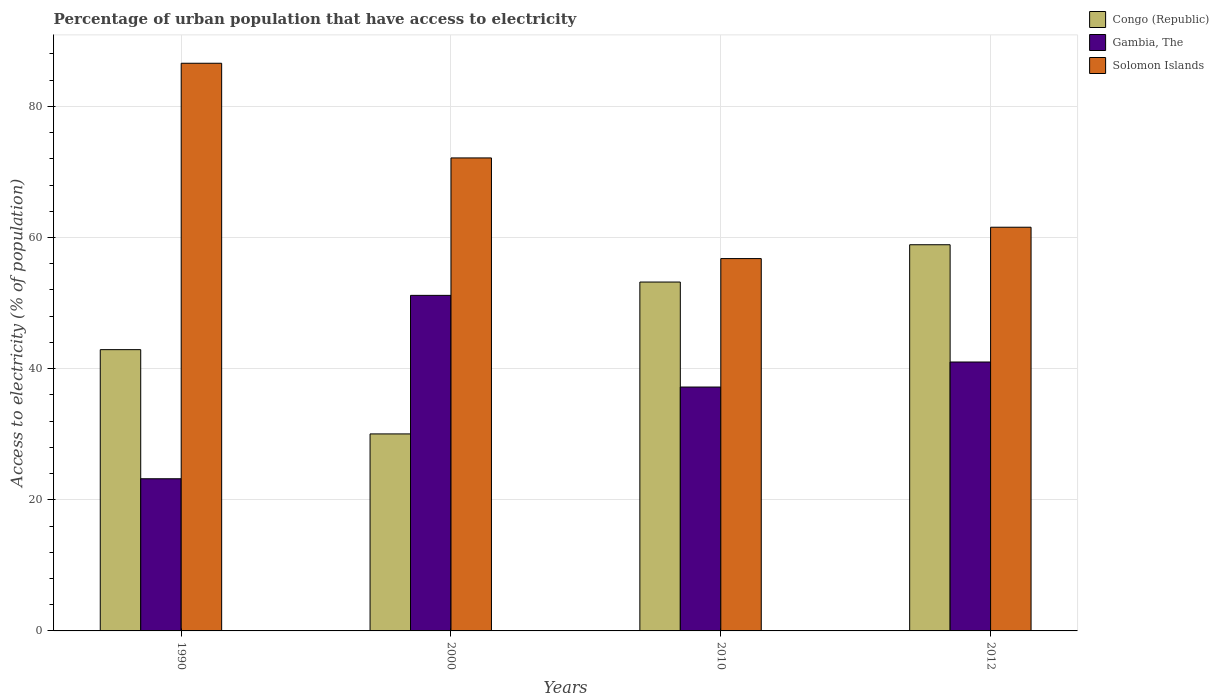How many different coloured bars are there?
Ensure brevity in your answer.  3. How many groups of bars are there?
Give a very brief answer. 4. Are the number of bars per tick equal to the number of legend labels?
Your response must be concise. Yes. How many bars are there on the 2nd tick from the left?
Make the answer very short. 3. What is the label of the 1st group of bars from the left?
Your answer should be compact. 1990. In how many cases, is the number of bars for a given year not equal to the number of legend labels?
Your answer should be very brief. 0. What is the percentage of urban population that have access to electricity in Solomon Islands in 2000?
Your answer should be compact. 72.14. Across all years, what is the maximum percentage of urban population that have access to electricity in Solomon Islands?
Ensure brevity in your answer.  86.58. Across all years, what is the minimum percentage of urban population that have access to electricity in Solomon Islands?
Your answer should be compact. 56.79. In which year was the percentage of urban population that have access to electricity in Congo (Republic) minimum?
Your answer should be compact. 2000. What is the total percentage of urban population that have access to electricity in Gambia, The in the graph?
Your answer should be compact. 152.6. What is the difference between the percentage of urban population that have access to electricity in Gambia, The in 1990 and that in 2010?
Offer a very short reply. -13.99. What is the difference between the percentage of urban population that have access to electricity in Congo (Republic) in 2000 and the percentage of urban population that have access to electricity in Gambia, The in 1990?
Your answer should be compact. 6.84. What is the average percentage of urban population that have access to electricity in Congo (Republic) per year?
Keep it short and to the point. 46.27. In the year 1990, what is the difference between the percentage of urban population that have access to electricity in Gambia, The and percentage of urban population that have access to electricity in Solomon Islands?
Ensure brevity in your answer.  -63.37. What is the ratio of the percentage of urban population that have access to electricity in Solomon Islands in 1990 to that in 2012?
Offer a terse response. 1.41. Is the difference between the percentage of urban population that have access to electricity in Gambia, The in 1990 and 2010 greater than the difference between the percentage of urban population that have access to electricity in Solomon Islands in 1990 and 2010?
Offer a very short reply. No. What is the difference between the highest and the second highest percentage of urban population that have access to electricity in Solomon Islands?
Make the answer very short. 14.44. What is the difference between the highest and the lowest percentage of urban population that have access to electricity in Solomon Islands?
Your answer should be compact. 29.79. Is the sum of the percentage of urban population that have access to electricity in Congo (Republic) in 1990 and 2010 greater than the maximum percentage of urban population that have access to electricity in Solomon Islands across all years?
Offer a terse response. Yes. What does the 3rd bar from the left in 2012 represents?
Your response must be concise. Solomon Islands. What does the 1st bar from the right in 2010 represents?
Offer a terse response. Solomon Islands. How many bars are there?
Offer a terse response. 12. Are all the bars in the graph horizontal?
Keep it short and to the point. No. How many years are there in the graph?
Your answer should be very brief. 4. Does the graph contain any zero values?
Offer a very short reply. No. Does the graph contain grids?
Provide a short and direct response. Yes. What is the title of the graph?
Ensure brevity in your answer.  Percentage of urban population that have access to electricity. Does "North America" appear as one of the legend labels in the graph?
Make the answer very short. No. What is the label or title of the Y-axis?
Offer a very short reply. Access to electricity (% of population). What is the Access to electricity (% of population) of Congo (Republic) in 1990?
Your answer should be compact. 42.9. What is the Access to electricity (% of population) of Gambia, The in 1990?
Provide a succinct answer. 23.21. What is the Access to electricity (% of population) of Solomon Islands in 1990?
Provide a succinct answer. 86.58. What is the Access to electricity (% of population) of Congo (Republic) in 2000?
Offer a very short reply. 30.05. What is the Access to electricity (% of population) of Gambia, The in 2000?
Offer a terse response. 51.18. What is the Access to electricity (% of population) of Solomon Islands in 2000?
Offer a very short reply. 72.14. What is the Access to electricity (% of population) in Congo (Republic) in 2010?
Make the answer very short. 53.21. What is the Access to electricity (% of population) of Gambia, The in 2010?
Offer a terse response. 37.2. What is the Access to electricity (% of population) in Solomon Islands in 2010?
Keep it short and to the point. 56.79. What is the Access to electricity (% of population) in Congo (Republic) in 2012?
Keep it short and to the point. 58.9. What is the Access to electricity (% of population) in Gambia, The in 2012?
Make the answer very short. 41.01. What is the Access to electricity (% of population) in Solomon Islands in 2012?
Your response must be concise. 61.57. Across all years, what is the maximum Access to electricity (% of population) in Congo (Republic)?
Offer a terse response. 58.9. Across all years, what is the maximum Access to electricity (% of population) of Gambia, The?
Provide a succinct answer. 51.18. Across all years, what is the maximum Access to electricity (% of population) in Solomon Islands?
Your answer should be very brief. 86.58. Across all years, what is the minimum Access to electricity (% of population) in Congo (Republic)?
Your answer should be very brief. 30.05. Across all years, what is the minimum Access to electricity (% of population) of Gambia, The?
Offer a very short reply. 23.21. Across all years, what is the minimum Access to electricity (% of population) in Solomon Islands?
Your answer should be compact. 56.79. What is the total Access to electricity (% of population) of Congo (Republic) in the graph?
Your answer should be very brief. 185.06. What is the total Access to electricity (% of population) in Gambia, The in the graph?
Your answer should be very brief. 152.6. What is the total Access to electricity (% of population) in Solomon Islands in the graph?
Ensure brevity in your answer.  277.08. What is the difference between the Access to electricity (% of population) in Congo (Republic) in 1990 and that in 2000?
Your answer should be very brief. 12.85. What is the difference between the Access to electricity (% of population) of Gambia, The in 1990 and that in 2000?
Make the answer very short. -27.97. What is the difference between the Access to electricity (% of population) in Solomon Islands in 1990 and that in 2000?
Give a very brief answer. 14.44. What is the difference between the Access to electricity (% of population) of Congo (Republic) in 1990 and that in 2010?
Provide a succinct answer. -10.31. What is the difference between the Access to electricity (% of population) of Gambia, The in 1990 and that in 2010?
Keep it short and to the point. -13.99. What is the difference between the Access to electricity (% of population) in Solomon Islands in 1990 and that in 2010?
Keep it short and to the point. 29.79. What is the difference between the Access to electricity (% of population) of Congo (Republic) in 1990 and that in 2012?
Provide a succinct answer. -16. What is the difference between the Access to electricity (% of population) in Gambia, The in 1990 and that in 2012?
Provide a succinct answer. -17.81. What is the difference between the Access to electricity (% of population) of Solomon Islands in 1990 and that in 2012?
Your answer should be compact. 25.01. What is the difference between the Access to electricity (% of population) of Congo (Republic) in 2000 and that in 2010?
Provide a succinct answer. -23.16. What is the difference between the Access to electricity (% of population) in Gambia, The in 2000 and that in 2010?
Your answer should be compact. 13.98. What is the difference between the Access to electricity (% of population) of Solomon Islands in 2000 and that in 2010?
Give a very brief answer. 15.35. What is the difference between the Access to electricity (% of population) of Congo (Republic) in 2000 and that in 2012?
Provide a short and direct response. -28.85. What is the difference between the Access to electricity (% of population) of Gambia, The in 2000 and that in 2012?
Your answer should be very brief. 10.16. What is the difference between the Access to electricity (% of population) in Solomon Islands in 2000 and that in 2012?
Provide a short and direct response. 10.57. What is the difference between the Access to electricity (% of population) of Congo (Republic) in 2010 and that in 2012?
Your response must be concise. -5.69. What is the difference between the Access to electricity (% of population) in Gambia, The in 2010 and that in 2012?
Ensure brevity in your answer.  -3.82. What is the difference between the Access to electricity (% of population) of Solomon Islands in 2010 and that in 2012?
Provide a succinct answer. -4.78. What is the difference between the Access to electricity (% of population) in Congo (Republic) in 1990 and the Access to electricity (% of population) in Gambia, The in 2000?
Offer a very short reply. -8.28. What is the difference between the Access to electricity (% of population) in Congo (Republic) in 1990 and the Access to electricity (% of population) in Solomon Islands in 2000?
Provide a short and direct response. -29.24. What is the difference between the Access to electricity (% of population) in Gambia, The in 1990 and the Access to electricity (% of population) in Solomon Islands in 2000?
Your answer should be very brief. -48.93. What is the difference between the Access to electricity (% of population) in Congo (Republic) in 1990 and the Access to electricity (% of population) in Gambia, The in 2010?
Make the answer very short. 5.7. What is the difference between the Access to electricity (% of population) of Congo (Republic) in 1990 and the Access to electricity (% of population) of Solomon Islands in 2010?
Keep it short and to the point. -13.89. What is the difference between the Access to electricity (% of population) of Gambia, The in 1990 and the Access to electricity (% of population) of Solomon Islands in 2010?
Provide a succinct answer. -33.58. What is the difference between the Access to electricity (% of population) of Congo (Republic) in 1990 and the Access to electricity (% of population) of Gambia, The in 2012?
Your answer should be very brief. 1.89. What is the difference between the Access to electricity (% of population) in Congo (Republic) in 1990 and the Access to electricity (% of population) in Solomon Islands in 2012?
Offer a terse response. -18.67. What is the difference between the Access to electricity (% of population) of Gambia, The in 1990 and the Access to electricity (% of population) of Solomon Islands in 2012?
Provide a short and direct response. -38.36. What is the difference between the Access to electricity (% of population) in Congo (Republic) in 2000 and the Access to electricity (% of population) in Gambia, The in 2010?
Provide a short and direct response. -7.15. What is the difference between the Access to electricity (% of population) in Congo (Republic) in 2000 and the Access to electricity (% of population) in Solomon Islands in 2010?
Your response must be concise. -26.74. What is the difference between the Access to electricity (% of population) of Gambia, The in 2000 and the Access to electricity (% of population) of Solomon Islands in 2010?
Offer a terse response. -5.61. What is the difference between the Access to electricity (% of population) of Congo (Republic) in 2000 and the Access to electricity (% of population) of Gambia, The in 2012?
Provide a short and direct response. -10.97. What is the difference between the Access to electricity (% of population) in Congo (Republic) in 2000 and the Access to electricity (% of population) in Solomon Islands in 2012?
Offer a terse response. -31.52. What is the difference between the Access to electricity (% of population) in Gambia, The in 2000 and the Access to electricity (% of population) in Solomon Islands in 2012?
Your response must be concise. -10.39. What is the difference between the Access to electricity (% of population) in Congo (Republic) in 2010 and the Access to electricity (% of population) in Gambia, The in 2012?
Your answer should be very brief. 12.2. What is the difference between the Access to electricity (% of population) in Congo (Republic) in 2010 and the Access to electricity (% of population) in Solomon Islands in 2012?
Provide a short and direct response. -8.36. What is the difference between the Access to electricity (% of population) of Gambia, The in 2010 and the Access to electricity (% of population) of Solomon Islands in 2012?
Provide a short and direct response. -24.37. What is the average Access to electricity (% of population) in Congo (Republic) per year?
Give a very brief answer. 46.27. What is the average Access to electricity (% of population) in Gambia, The per year?
Your response must be concise. 38.15. What is the average Access to electricity (% of population) in Solomon Islands per year?
Offer a very short reply. 69.27. In the year 1990, what is the difference between the Access to electricity (% of population) of Congo (Republic) and Access to electricity (% of population) of Gambia, The?
Your answer should be very brief. 19.69. In the year 1990, what is the difference between the Access to electricity (% of population) in Congo (Republic) and Access to electricity (% of population) in Solomon Islands?
Your response must be concise. -43.68. In the year 1990, what is the difference between the Access to electricity (% of population) of Gambia, The and Access to electricity (% of population) of Solomon Islands?
Provide a succinct answer. -63.37. In the year 2000, what is the difference between the Access to electricity (% of population) in Congo (Republic) and Access to electricity (% of population) in Gambia, The?
Your answer should be compact. -21.13. In the year 2000, what is the difference between the Access to electricity (% of population) of Congo (Republic) and Access to electricity (% of population) of Solomon Islands?
Keep it short and to the point. -42.09. In the year 2000, what is the difference between the Access to electricity (% of population) of Gambia, The and Access to electricity (% of population) of Solomon Islands?
Make the answer very short. -20.96. In the year 2010, what is the difference between the Access to electricity (% of population) of Congo (Republic) and Access to electricity (% of population) of Gambia, The?
Ensure brevity in your answer.  16.02. In the year 2010, what is the difference between the Access to electricity (% of population) of Congo (Republic) and Access to electricity (% of population) of Solomon Islands?
Ensure brevity in your answer.  -3.58. In the year 2010, what is the difference between the Access to electricity (% of population) in Gambia, The and Access to electricity (% of population) in Solomon Islands?
Ensure brevity in your answer.  -19.59. In the year 2012, what is the difference between the Access to electricity (% of population) of Congo (Republic) and Access to electricity (% of population) of Gambia, The?
Make the answer very short. 17.89. In the year 2012, what is the difference between the Access to electricity (% of population) in Congo (Republic) and Access to electricity (% of population) in Solomon Islands?
Your response must be concise. -2.67. In the year 2012, what is the difference between the Access to electricity (% of population) in Gambia, The and Access to electricity (% of population) in Solomon Islands?
Provide a short and direct response. -20.56. What is the ratio of the Access to electricity (% of population) of Congo (Republic) in 1990 to that in 2000?
Your response must be concise. 1.43. What is the ratio of the Access to electricity (% of population) in Gambia, The in 1990 to that in 2000?
Make the answer very short. 0.45. What is the ratio of the Access to electricity (% of population) in Solomon Islands in 1990 to that in 2000?
Your response must be concise. 1.2. What is the ratio of the Access to electricity (% of population) of Congo (Republic) in 1990 to that in 2010?
Your answer should be compact. 0.81. What is the ratio of the Access to electricity (% of population) in Gambia, The in 1990 to that in 2010?
Ensure brevity in your answer.  0.62. What is the ratio of the Access to electricity (% of population) of Solomon Islands in 1990 to that in 2010?
Your answer should be compact. 1.52. What is the ratio of the Access to electricity (% of population) of Congo (Republic) in 1990 to that in 2012?
Provide a short and direct response. 0.73. What is the ratio of the Access to electricity (% of population) of Gambia, The in 1990 to that in 2012?
Offer a terse response. 0.57. What is the ratio of the Access to electricity (% of population) in Solomon Islands in 1990 to that in 2012?
Offer a terse response. 1.41. What is the ratio of the Access to electricity (% of population) of Congo (Republic) in 2000 to that in 2010?
Provide a short and direct response. 0.56. What is the ratio of the Access to electricity (% of population) in Gambia, The in 2000 to that in 2010?
Provide a short and direct response. 1.38. What is the ratio of the Access to electricity (% of population) in Solomon Islands in 2000 to that in 2010?
Keep it short and to the point. 1.27. What is the ratio of the Access to electricity (% of population) in Congo (Republic) in 2000 to that in 2012?
Make the answer very short. 0.51. What is the ratio of the Access to electricity (% of population) in Gambia, The in 2000 to that in 2012?
Offer a very short reply. 1.25. What is the ratio of the Access to electricity (% of population) in Solomon Islands in 2000 to that in 2012?
Offer a very short reply. 1.17. What is the ratio of the Access to electricity (% of population) in Congo (Republic) in 2010 to that in 2012?
Your response must be concise. 0.9. What is the ratio of the Access to electricity (% of population) in Gambia, The in 2010 to that in 2012?
Offer a very short reply. 0.91. What is the ratio of the Access to electricity (% of population) in Solomon Islands in 2010 to that in 2012?
Your answer should be compact. 0.92. What is the difference between the highest and the second highest Access to electricity (% of population) of Congo (Republic)?
Provide a short and direct response. 5.69. What is the difference between the highest and the second highest Access to electricity (% of population) in Gambia, The?
Offer a terse response. 10.16. What is the difference between the highest and the second highest Access to electricity (% of population) in Solomon Islands?
Give a very brief answer. 14.44. What is the difference between the highest and the lowest Access to electricity (% of population) in Congo (Republic)?
Offer a terse response. 28.85. What is the difference between the highest and the lowest Access to electricity (% of population) in Gambia, The?
Your response must be concise. 27.97. What is the difference between the highest and the lowest Access to electricity (% of population) in Solomon Islands?
Keep it short and to the point. 29.79. 